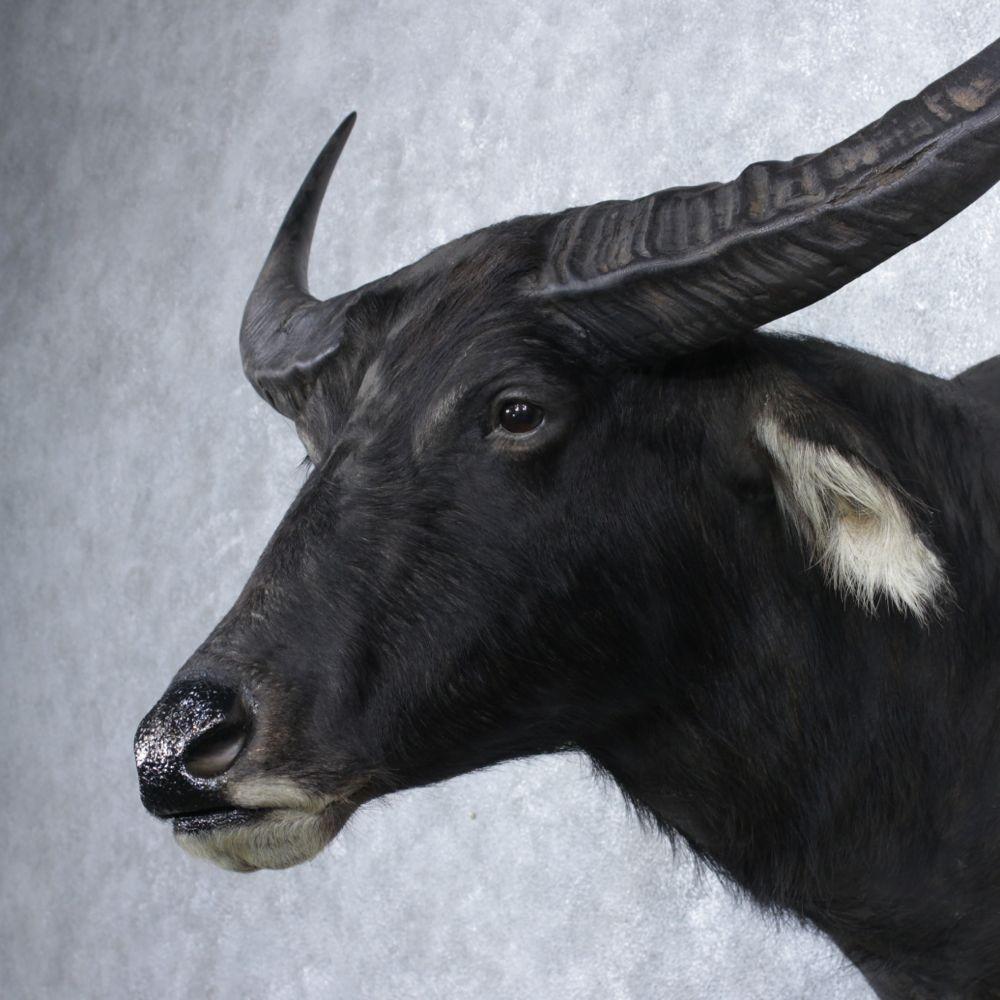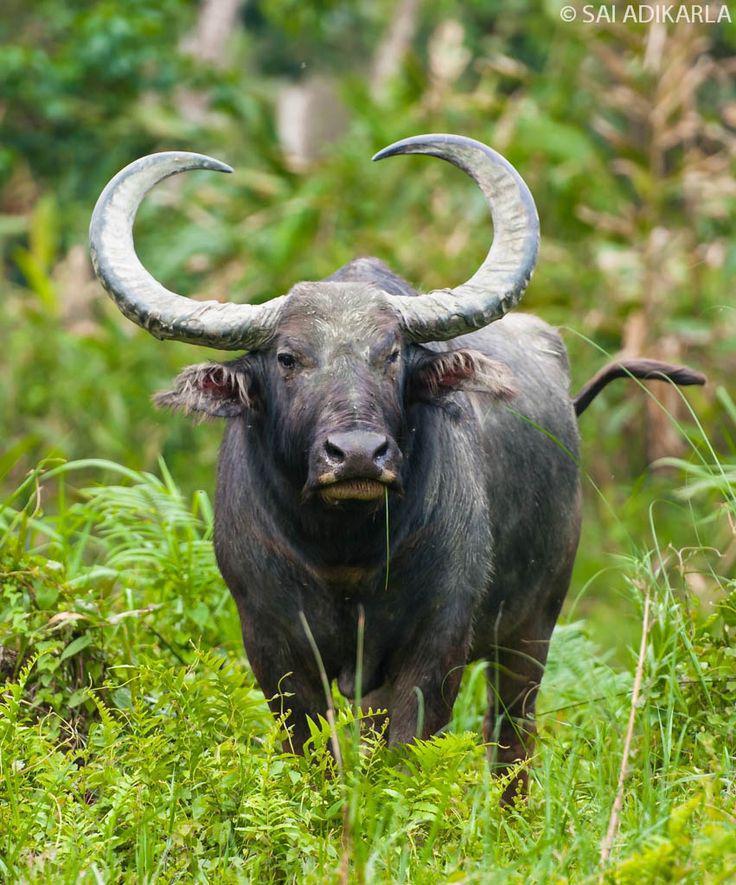The first image is the image on the left, the second image is the image on the right. For the images displayed, is the sentence "The horned animal on the left looks directly at the camera." factually correct? Answer yes or no. No. The first image is the image on the left, the second image is the image on the right. Considering the images on both sides, is "In each image the water buffalo's horns are completely visible." valid? Answer yes or no. No. 